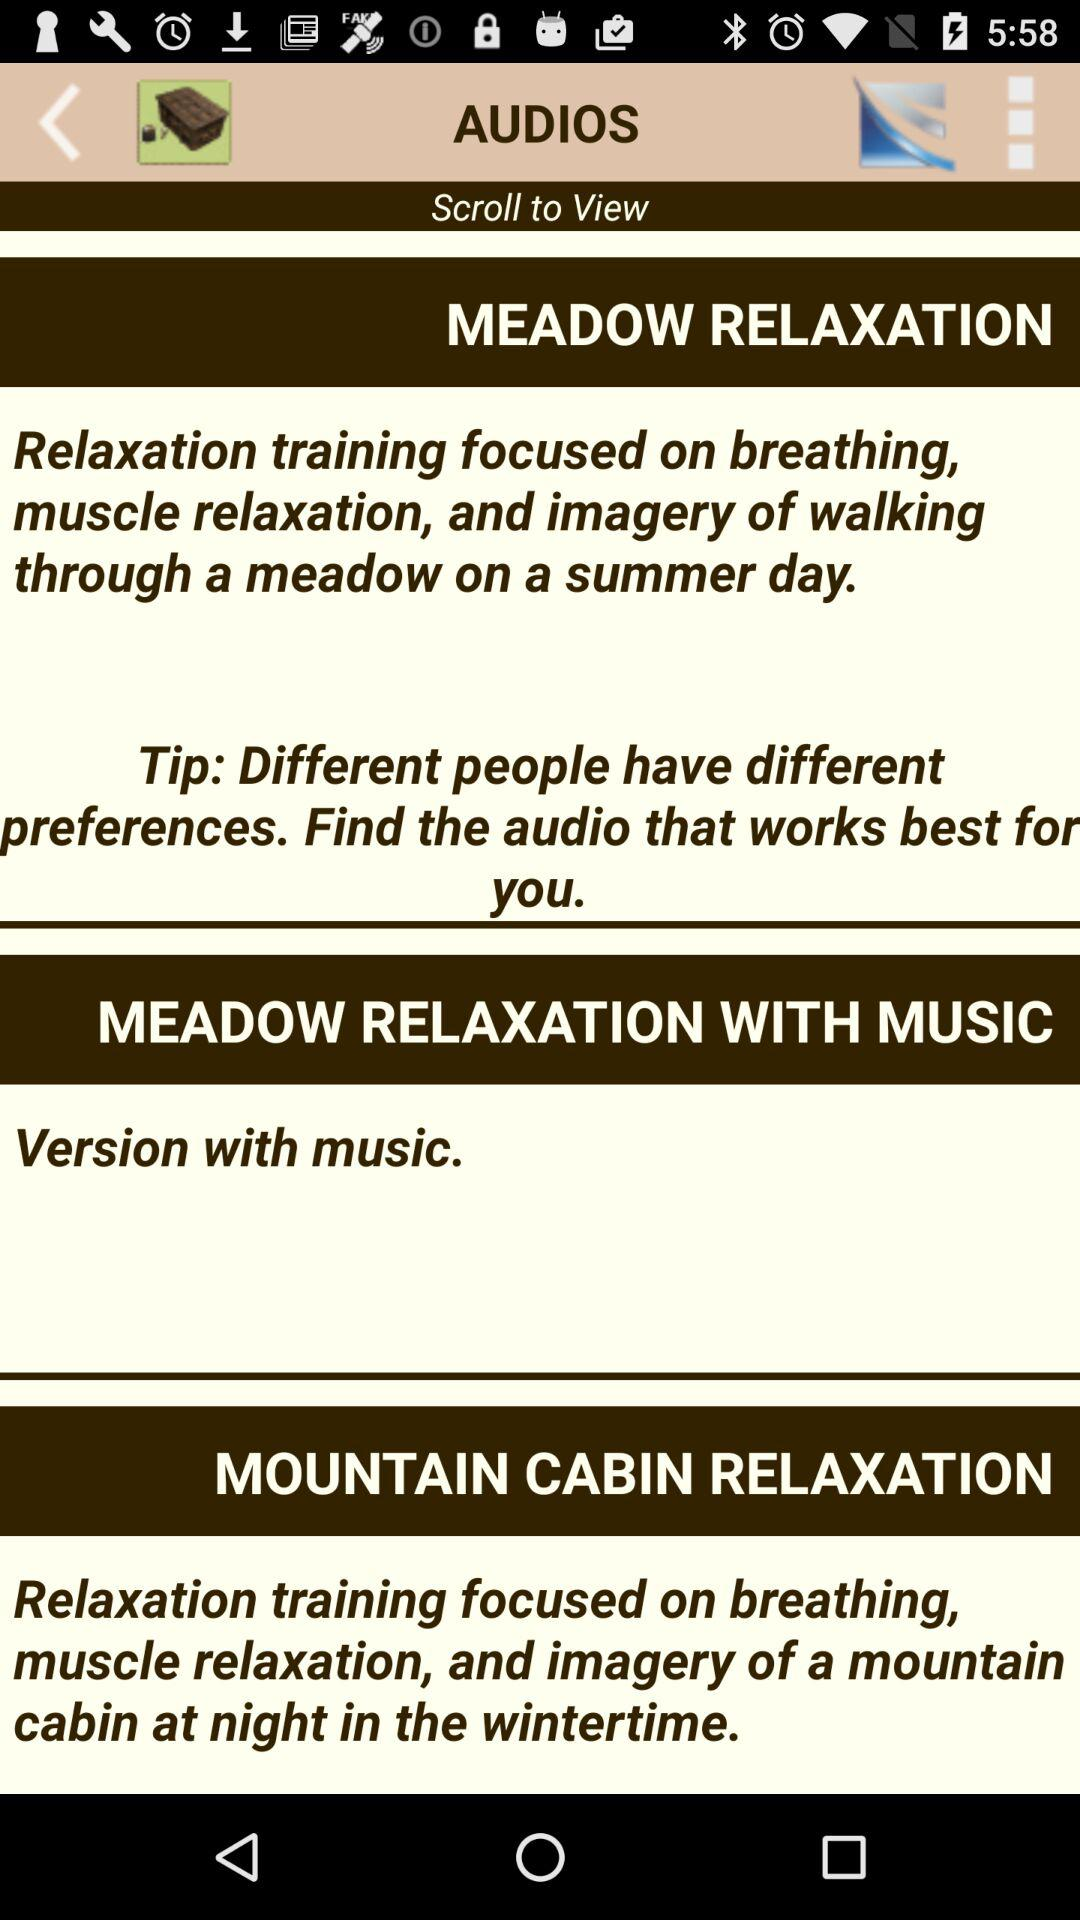How many audios are there in total?
Answer the question using a single word or phrase. 3 